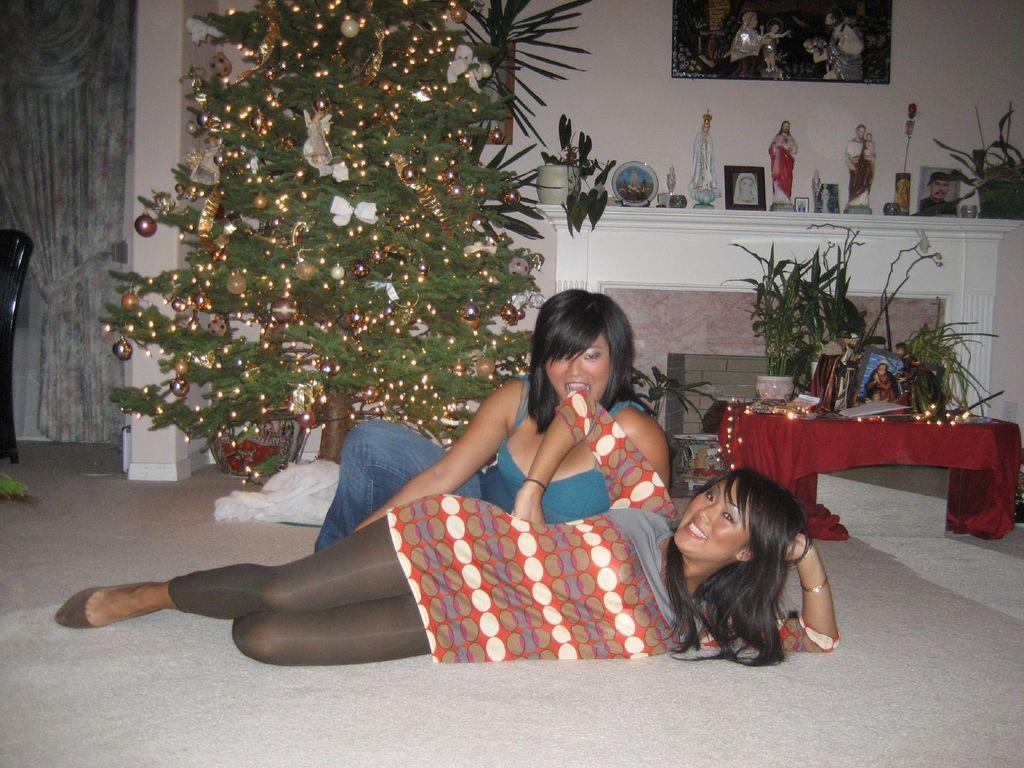Could you give a brief overview of what you see in this image? In this image, we can see a woman lying on the floor and smiling. Behind her we can see another woman. In the background, we can see a christmas tree with decorative objects, firehouse, table covered with cloth, shelf and wall with picture frames. On the shelf and table, we can see house plants and show pieces. On the left side of the image, there is a chair on the floor. 